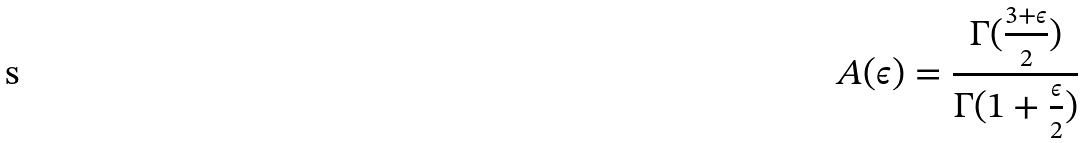<formula> <loc_0><loc_0><loc_500><loc_500>A ( \epsilon ) = \frac { \Gamma ( \frac { 3 + \epsilon } { 2 } ) } { \Gamma ( 1 + \frac { \epsilon } { 2 } ) }</formula> 